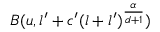<formula> <loc_0><loc_0><loc_500><loc_500>B ( u , l ^ { \prime } + c ^ { \prime } ( l + l ^ { \prime } ) ^ { \frac { \alpha } { d + 1 } } )</formula> 